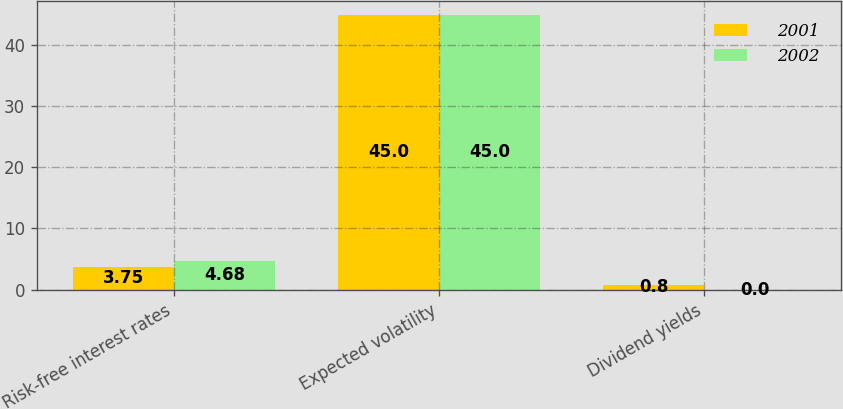Convert chart to OTSL. <chart><loc_0><loc_0><loc_500><loc_500><stacked_bar_chart><ecel><fcel>Risk-free interest rates<fcel>Expected volatility<fcel>Dividend yields<nl><fcel>2001<fcel>3.75<fcel>45<fcel>0.8<nl><fcel>2002<fcel>4.68<fcel>45<fcel>0<nl></chart> 